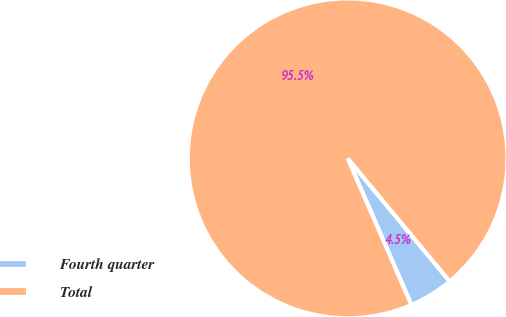Convert chart. <chart><loc_0><loc_0><loc_500><loc_500><pie_chart><fcel>Fourth quarter<fcel>Total<nl><fcel>4.49%<fcel>95.51%<nl></chart> 